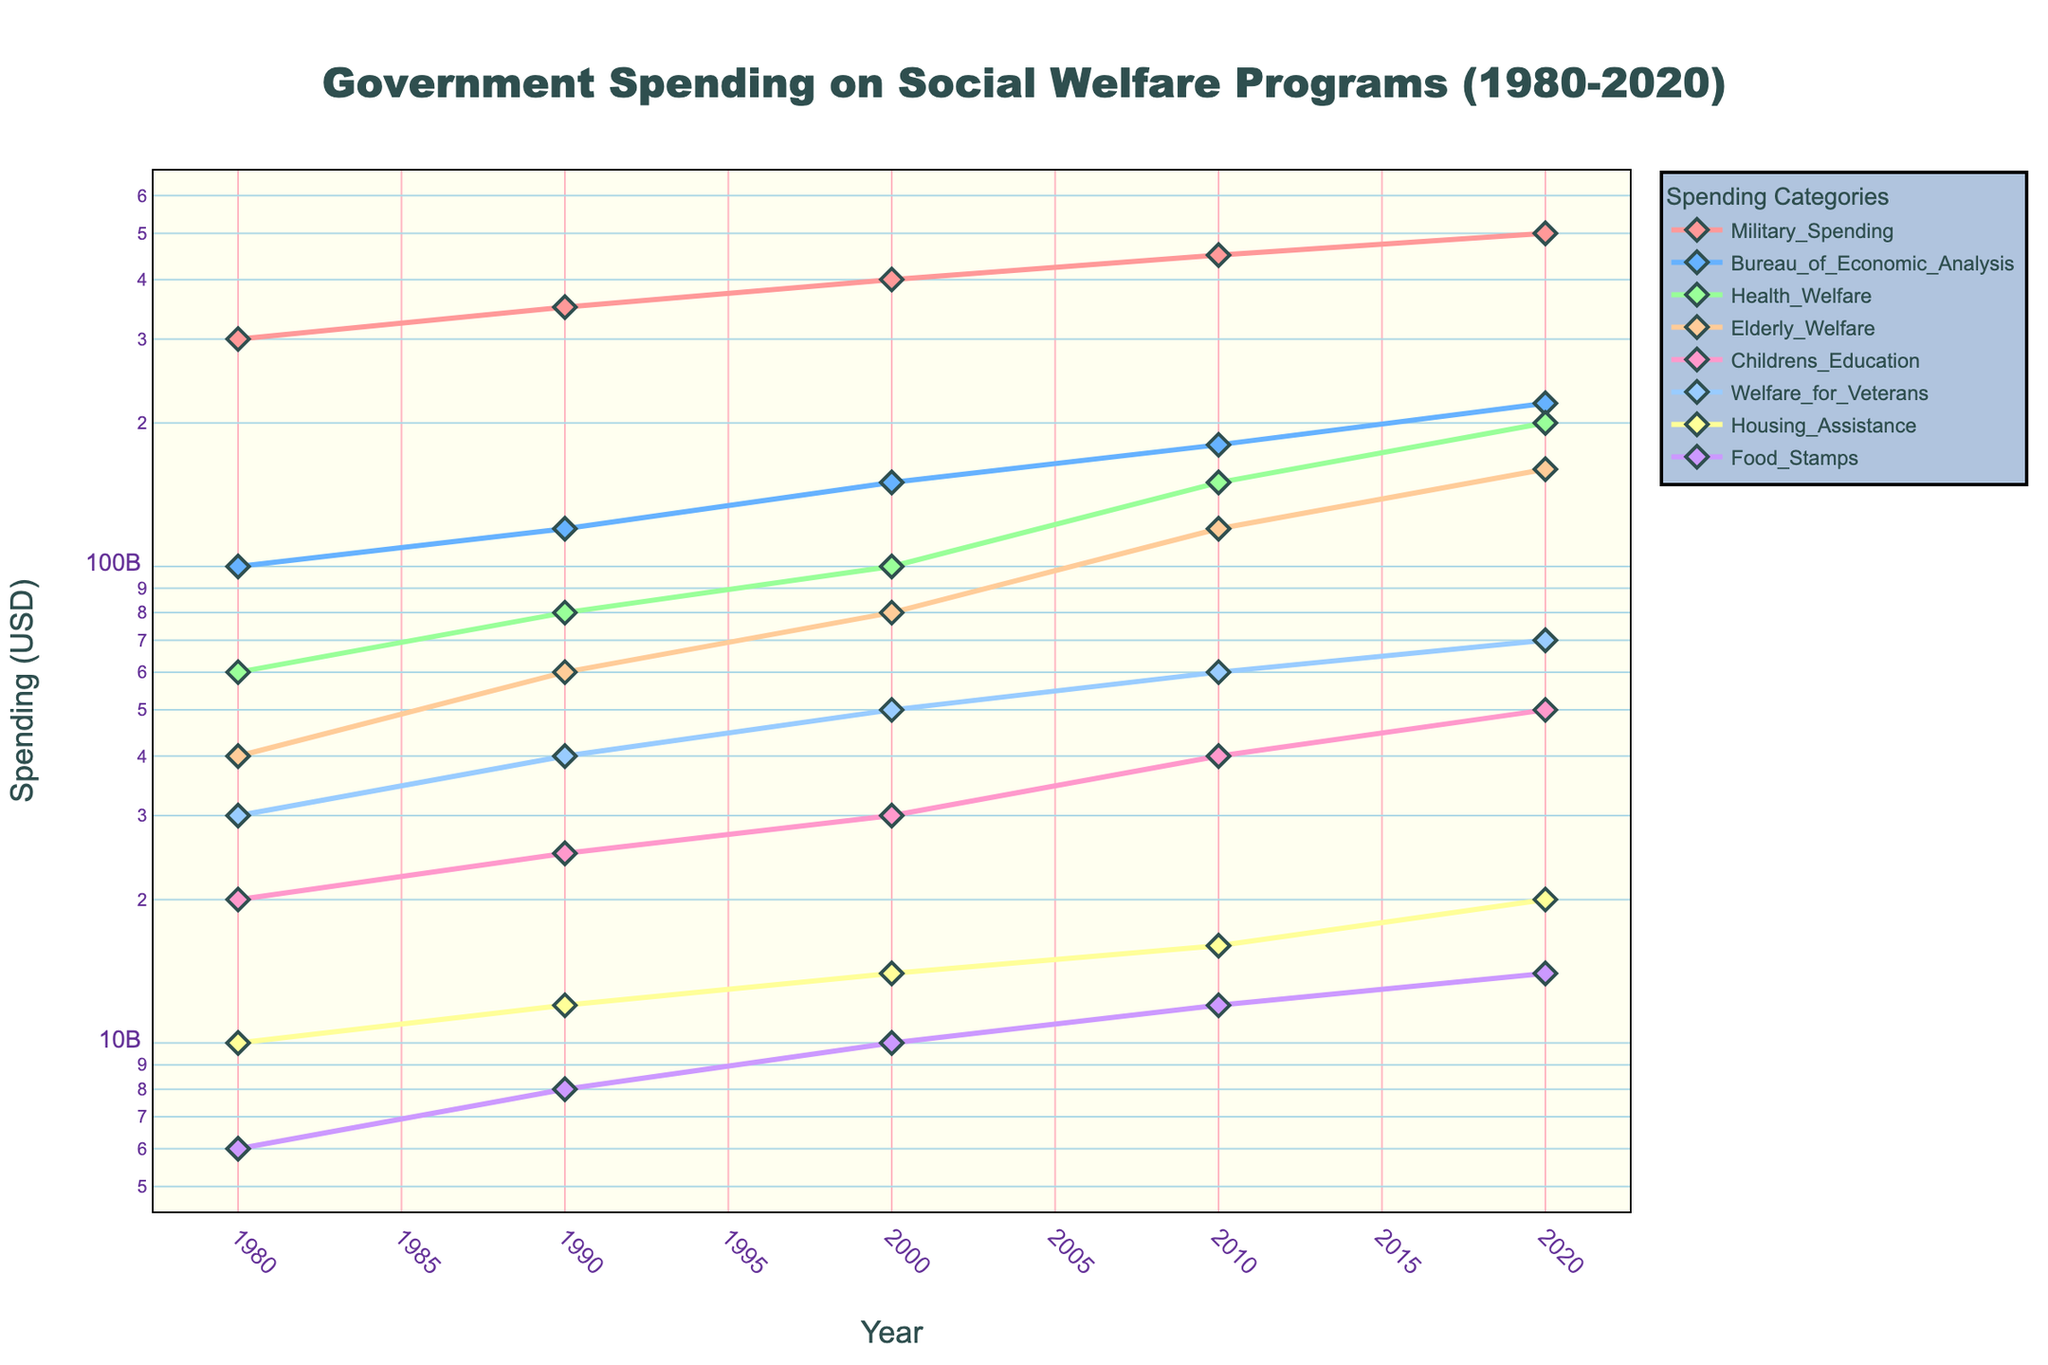What's the title of the plot? Look at the text at the top of the plot that describes what the plot is about.
Answer: Government Spending on Social Welfare Programs (1980-2020) What is the y-axis title? Look at the label on the vertical axis of the plot which indicates what the y-values represent.
Answer: Spending (USD) Which spending category had the highest spending in 2020? Observe the point on the plot for the year 2020 and find the category with the highest value on the y-axis.
Answer: Military Spending How did Health & Welfare spending change from 1980 to 2020? Look at the Health & Welfare line and compare its values at the start (1980) and end (2020) of the period.
Answer: Increased by $140 billion Which two categories showed a similar trend over the decades? Compare the lines in the plot to find two categories whose shapes over time resemble each other.
Answer: Elderly Welfare and Health & Welfare How does the trend in Children's Education spending compare to Food Stamps spending from 1980 to 2020? Evaluate both lines from 1980 to 2020 and see whether they increased or decreased and by how much.
Answer: Both increased, with Children's Education seeing a greater rise Looking at the log scale, how many orders of magnitude is the range of spending values on the y-axis? Determine the highest and lowest points on the y-axis and note the number of intervals between the two values.
Answer: Three orders of magnitude What is the overall trend of Military Spending from 1980 to 2020? Look at the Military Spending line and describe its progression over time.
Answer: Steady increase Which three categories had the highest growth rate from 1980 to 2020? Identify the categories with the steepest slopes between 1980 and 2020.
Answer: Health & Welfare, Elderly Welfare, Bureau of Economic Analysis 